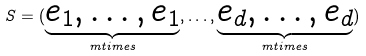Convert formula to latex. <formula><loc_0><loc_0><loc_500><loc_500>S = ( { \underbrace { e _ { 1 } , \dots , e _ { 1 } } _ { m t i m e s } } , \dots , { \underbrace { e _ { d } , \dots , e _ { d } } _ { m t i m e s } } )</formula> 